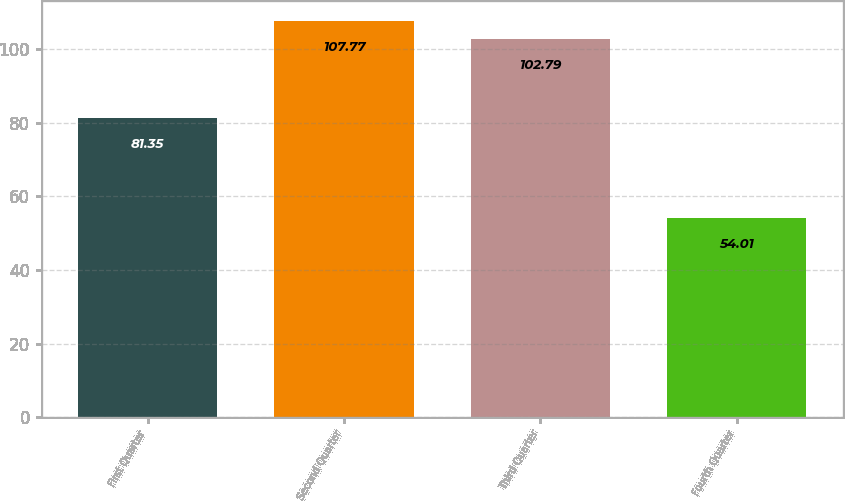Convert chart to OTSL. <chart><loc_0><loc_0><loc_500><loc_500><bar_chart><fcel>First Quarter<fcel>Second Quarter<fcel>Third Quarter<fcel>Fourth Quarter<nl><fcel>81.35<fcel>107.77<fcel>102.79<fcel>54.01<nl></chart> 